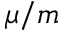Convert formula to latex. <formula><loc_0><loc_0><loc_500><loc_500>\mu / m</formula> 